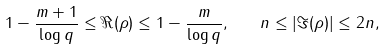Convert formula to latex. <formula><loc_0><loc_0><loc_500><loc_500>1 - \frac { m + 1 } { \log { q } } \leq \Re ( \rho ) \leq 1 - \frac { m } { \log { q } } , \quad n \leq | \Im ( \rho ) | \leq 2 n ,</formula> 